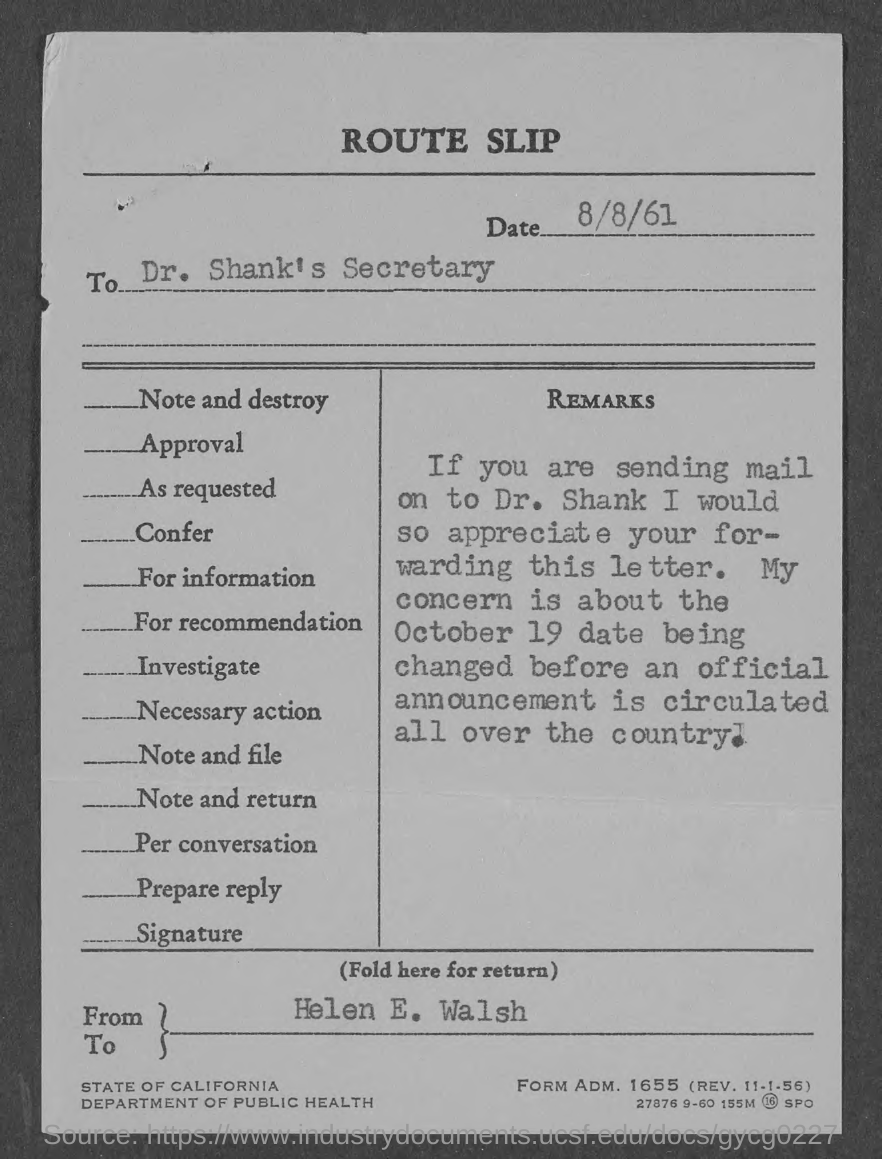What is the date mentioned in the route slip ?
Keep it short and to the point. 8/8/61. To whom this was written ?
Your response must be concise. DR. SHANK'S SECRETARY. What is the name of the department mentioned in the given route slip ?
Your answer should be very brief. Department of public health. What is the form adm. no mentioned in the given route slip ?
Provide a short and direct response. 1655. 